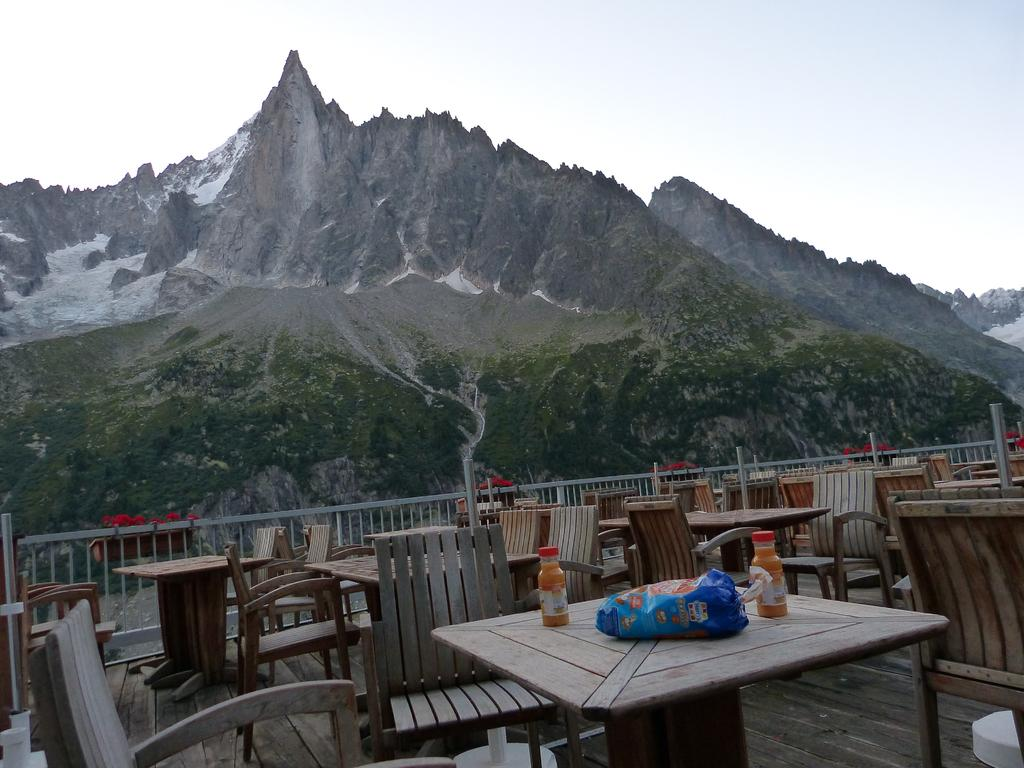What type of furniture is present in the image? There are tables and chairs in the image. What is located near the tables? There is a fence in the image. What items can be seen on the table? There are bottles and a plastic packet on the table. What can be seen in the background of the image? The sky, clouds, and hills are visible in the background of the image. Can you tell me how many chickens are involved in the fight in the image? There are no chickens or fights present in the image. What hobbies do the people in the image engage in? The image does not show any people, so their hobbies cannot be determined. 